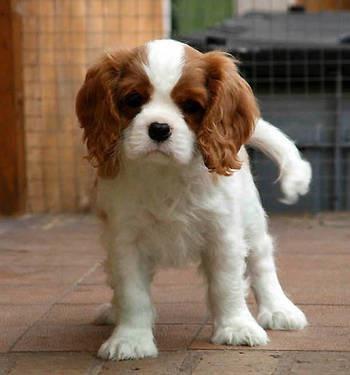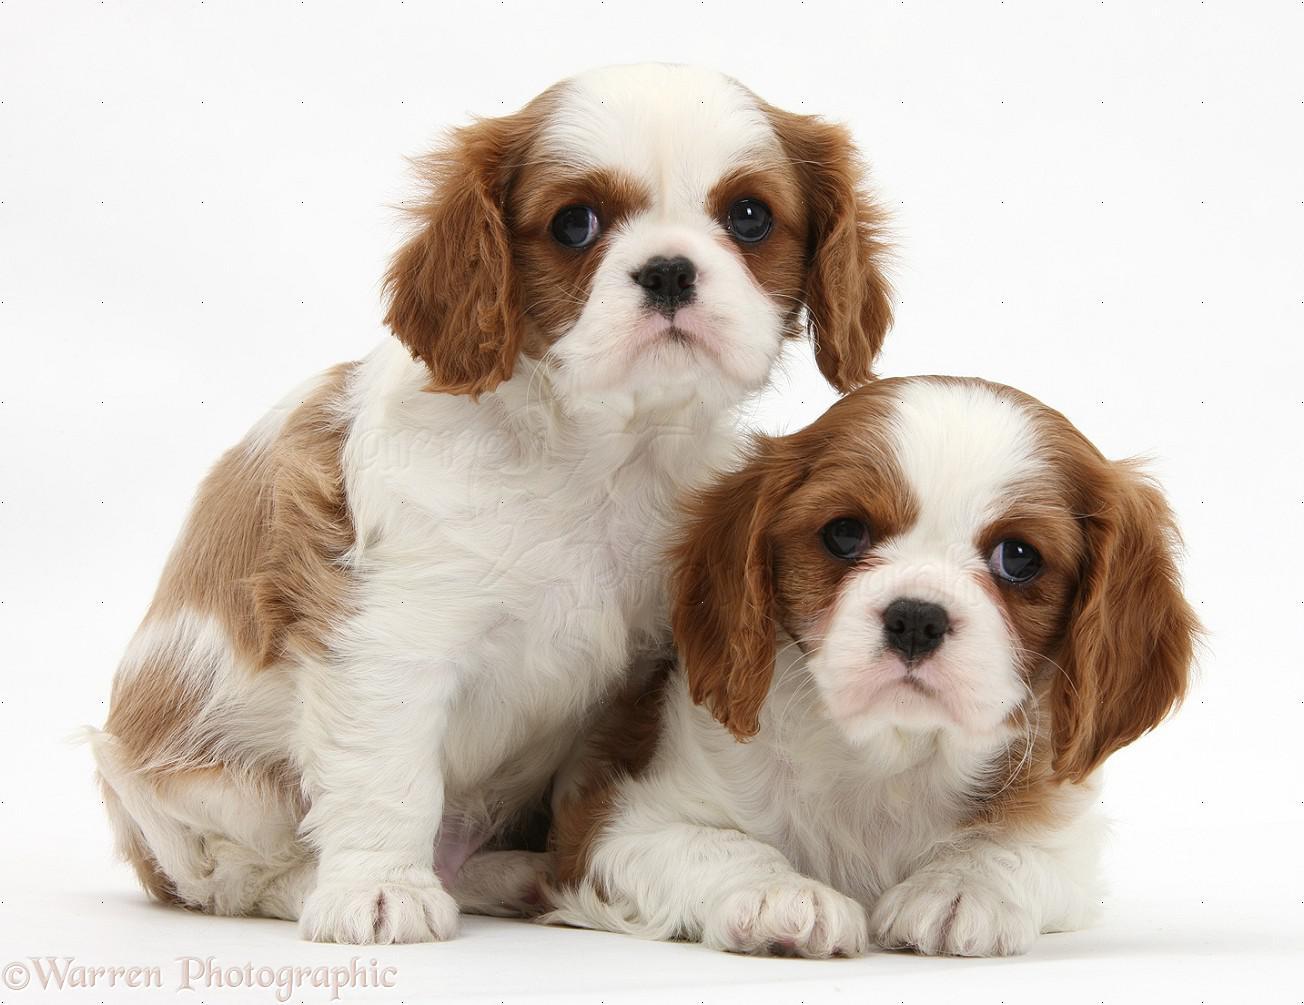The first image is the image on the left, the second image is the image on the right. Given the left and right images, does the statement "There are three dogs" hold true? Answer yes or no. Yes. 